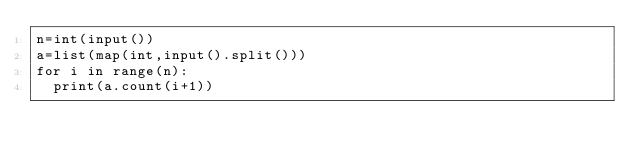Convert code to text. <code><loc_0><loc_0><loc_500><loc_500><_Python_>n=int(input())
a=list(map(int,input().split()))
for i in range(n):
  print(a.count(i+1))</code> 